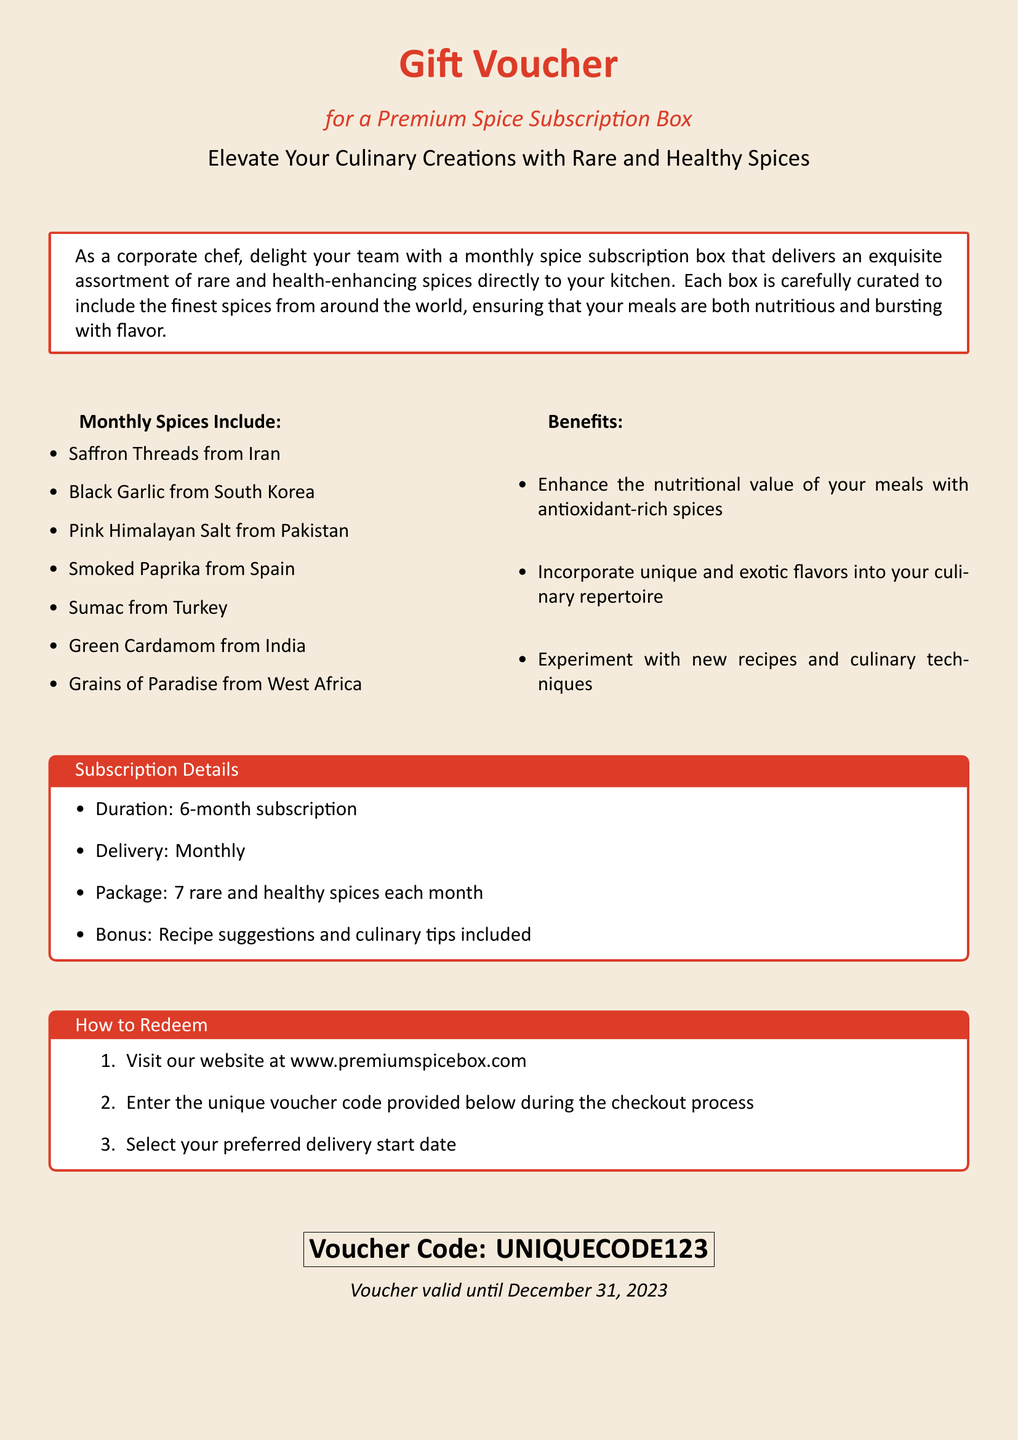What is the title of this voucher? The title of the voucher is prominently displayed at the top of the document in a large font.
Answer: Gift Voucher What is the duration of the subscription? The duration of the subscription is stated in the section detailing subscription details.
Answer: 6-month subscription How many spices are included each month? The number of spices provided each month can be found in the subscription details box.
Answer: 7 rare and healthy spices What is the unique voucher code? The unique voucher code is found in a box near the bottom of the document.
Answer: UNIQUECODE123 What benefits does the subscription provide? The benefits are listed in a specific section of the document, highlighting the advantages of the spices.
Answer: Enhance the nutritional value of your meals with antioxidant-rich spices How can one redeem the voucher? The redemption process is explained in a step-by-step format in the document.
Answer: Visit our website at www.premiumspicebox.com When is the voucher valid until? The validity period of the voucher is stated near the voucher code.
Answer: December 31, 2023 What is included with the spices each month? The document mentions additional items included with the spice delivery in the subscription details.
Answer: Recipe suggestions and culinary tips What type of spices are featured in the subscription? The specific spices included each month are listed under "Monthly Spices Include."
Answer: Saffron Threads from Iran, Black Garlic from South Korea, etc 